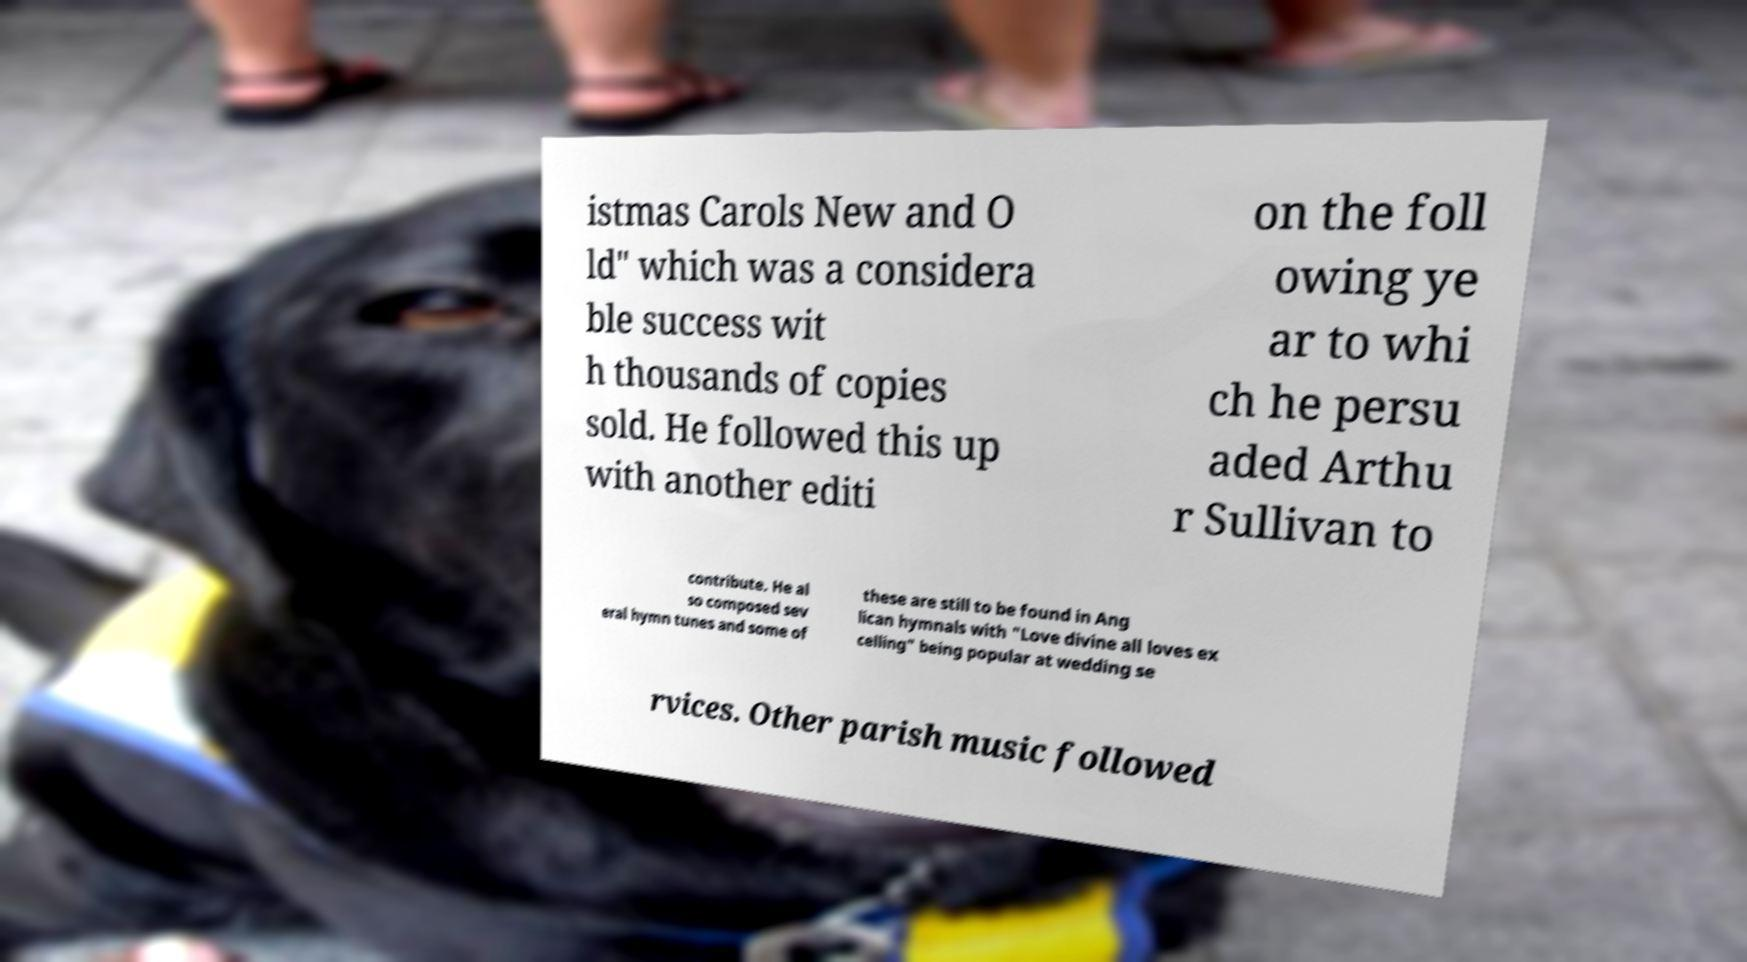Could you extract and type out the text from this image? istmas Carols New and O ld" which was a considera ble success wit h thousands of copies sold. He followed this up with another editi on the foll owing ye ar to whi ch he persu aded Arthu r Sullivan to contribute. He al so composed sev eral hymn tunes and some of these are still to be found in Ang lican hymnals with "Love divine all loves ex celling" being popular at wedding se rvices. Other parish music followed 